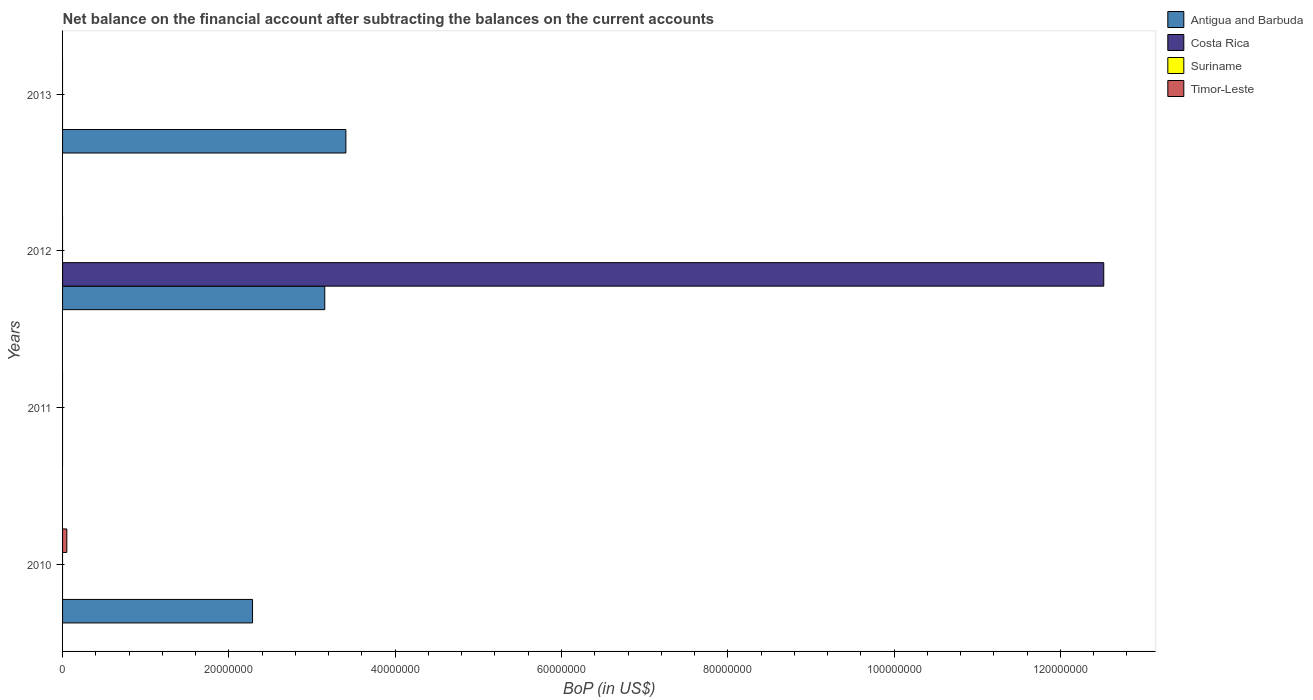How many different coloured bars are there?
Provide a short and direct response. 3. Are the number of bars per tick equal to the number of legend labels?
Offer a very short reply. No. How many bars are there on the 2nd tick from the top?
Your response must be concise. 2. How many bars are there on the 1st tick from the bottom?
Provide a short and direct response. 2. What is the label of the 2nd group of bars from the top?
Offer a very short reply. 2012. What is the Balance of Payments in Antigua and Barbuda in 2013?
Provide a short and direct response. 3.41e+07. Across all years, what is the maximum Balance of Payments in Antigua and Barbuda?
Offer a very short reply. 3.41e+07. In which year was the Balance of Payments in Antigua and Barbuda maximum?
Make the answer very short. 2013. What is the total Balance of Payments in Antigua and Barbuda in the graph?
Offer a very short reply. 8.84e+07. What is the difference between the Balance of Payments in Antigua and Barbuda in 2010 and that in 2012?
Give a very brief answer. -8.69e+06. What is the difference between the Balance of Payments in Antigua and Barbuda in 2013 and the Balance of Payments in Suriname in 2012?
Your answer should be compact. 3.41e+07. In the year 2012, what is the difference between the Balance of Payments in Antigua and Barbuda and Balance of Payments in Costa Rica?
Provide a short and direct response. -9.37e+07. What is the ratio of the Balance of Payments in Antigua and Barbuda in 2010 to that in 2013?
Ensure brevity in your answer.  0.67. What is the difference between the highest and the second highest Balance of Payments in Antigua and Barbuda?
Keep it short and to the point. 2.54e+06. What is the difference between the highest and the lowest Balance of Payments in Antigua and Barbuda?
Your answer should be very brief. 3.41e+07. In how many years, is the Balance of Payments in Costa Rica greater than the average Balance of Payments in Costa Rica taken over all years?
Make the answer very short. 1. Is it the case that in every year, the sum of the Balance of Payments in Suriname and Balance of Payments in Timor-Leste is greater than the sum of Balance of Payments in Antigua and Barbuda and Balance of Payments in Costa Rica?
Ensure brevity in your answer.  No. Is it the case that in every year, the sum of the Balance of Payments in Antigua and Barbuda and Balance of Payments in Costa Rica is greater than the Balance of Payments in Timor-Leste?
Your answer should be compact. No. How many bars are there?
Keep it short and to the point. 5. How many years are there in the graph?
Keep it short and to the point. 4. What is the difference between two consecutive major ticks on the X-axis?
Give a very brief answer. 2.00e+07. Are the values on the major ticks of X-axis written in scientific E-notation?
Offer a very short reply. No. Does the graph contain any zero values?
Your answer should be compact. Yes. Does the graph contain grids?
Your response must be concise. No. Where does the legend appear in the graph?
Provide a short and direct response. Top right. How many legend labels are there?
Your response must be concise. 4. What is the title of the graph?
Ensure brevity in your answer.  Net balance on the financial account after subtracting the balances on the current accounts. Does "Brunei Darussalam" appear as one of the legend labels in the graph?
Ensure brevity in your answer.  No. What is the label or title of the X-axis?
Provide a succinct answer. BoP (in US$). What is the label or title of the Y-axis?
Give a very brief answer. Years. What is the BoP (in US$) of Antigua and Barbuda in 2010?
Make the answer very short. 2.28e+07. What is the BoP (in US$) in Timor-Leste in 2010?
Provide a succinct answer. 5.13e+05. What is the BoP (in US$) in Costa Rica in 2011?
Make the answer very short. 0. What is the BoP (in US$) of Antigua and Barbuda in 2012?
Offer a terse response. 3.15e+07. What is the BoP (in US$) in Costa Rica in 2012?
Your answer should be compact. 1.25e+08. What is the BoP (in US$) in Antigua and Barbuda in 2013?
Ensure brevity in your answer.  3.41e+07. What is the BoP (in US$) of Costa Rica in 2013?
Offer a very short reply. 0. What is the BoP (in US$) in Suriname in 2013?
Your response must be concise. 0. What is the BoP (in US$) of Timor-Leste in 2013?
Ensure brevity in your answer.  0. Across all years, what is the maximum BoP (in US$) of Antigua and Barbuda?
Offer a terse response. 3.41e+07. Across all years, what is the maximum BoP (in US$) in Costa Rica?
Ensure brevity in your answer.  1.25e+08. Across all years, what is the maximum BoP (in US$) of Timor-Leste?
Offer a terse response. 5.13e+05. Across all years, what is the minimum BoP (in US$) in Timor-Leste?
Offer a terse response. 0. What is the total BoP (in US$) in Antigua and Barbuda in the graph?
Make the answer very short. 8.84e+07. What is the total BoP (in US$) of Costa Rica in the graph?
Provide a succinct answer. 1.25e+08. What is the total BoP (in US$) of Suriname in the graph?
Your answer should be compact. 0. What is the total BoP (in US$) of Timor-Leste in the graph?
Give a very brief answer. 5.13e+05. What is the difference between the BoP (in US$) of Antigua and Barbuda in 2010 and that in 2012?
Give a very brief answer. -8.69e+06. What is the difference between the BoP (in US$) in Antigua and Barbuda in 2010 and that in 2013?
Keep it short and to the point. -1.12e+07. What is the difference between the BoP (in US$) in Antigua and Barbuda in 2012 and that in 2013?
Your answer should be compact. -2.54e+06. What is the difference between the BoP (in US$) of Antigua and Barbuda in 2010 and the BoP (in US$) of Costa Rica in 2012?
Your answer should be very brief. -1.02e+08. What is the average BoP (in US$) of Antigua and Barbuda per year?
Make the answer very short. 2.21e+07. What is the average BoP (in US$) of Costa Rica per year?
Ensure brevity in your answer.  3.13e+07. What is the average BoP (in US$) of Timor-Leste per year?
Keep it short and to the point. 1.28e+05. In the year 2010, what is the difference between the BoP (in US$) of Antigua and Barbuda and BoP (in US$) of Timor-Leste?
Provide a succinct answer. 2.23e+07. In the year 2012, what is the difference between the BoP (in US$) in Antigua and Barbuda and BoP (in US$) in Costa Rica?
Provide a short and direct response. -9.37e+07. What is the ratio of the BoP (in US$) in Antigua and Barbuda in 2010 to that in 2012?
Make the answer very short. 0.72. What is the ratio of the BoP (in US$) of Antigua and Barbuda in 2010 to that in 2013?
Offer a very short reply. 0.67. What is the ratio of the BoP (in US$) in Antigua and Barbuda in 2012 to that in 2013?
Offer a terse response. 0.93. What is the difference between the highest and the second highest BoP (in US$) in Antigua and Barbuda?
Offer a terse response. 2.54e+06. What is the difference between the highest and the lowest BoP (in US$) in Antigua and Barbuda?
Offer a very short reply. 3.41e+07. What is the difference between the highest and the lowest BoP (in US$) in Costa Rica?
Your answer should be very brief. 1.25e+08. What is the difference between the highest and the lowest BoP (in US$) of Timor-Leste?
Your response must be concise. 5.13e+05. 